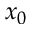Convert formula to latex. <formula><loc_0><loc_0><loc_500><loc_500>x _ { 0 }</formula> 